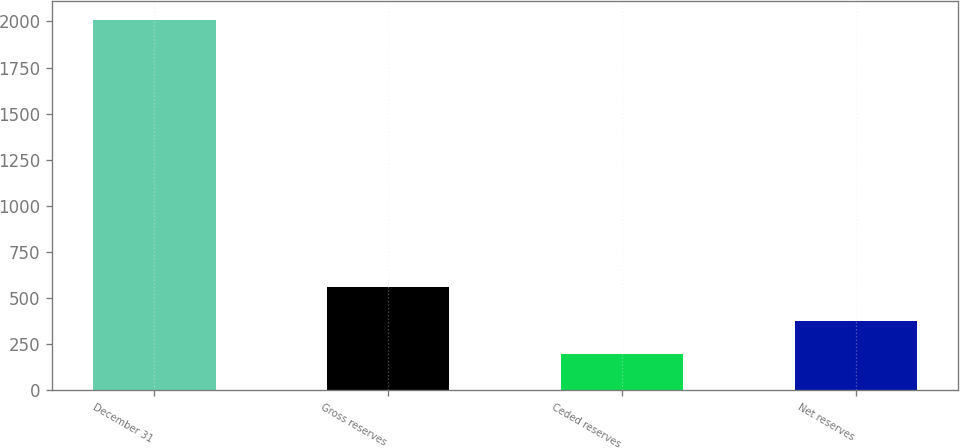Convert chart to OTSL. <chart><loc_0><loc_0><loc_500><loc_500><bar_chart><fcel>December 31<fcel>Gross reserves<fcel>Ceded reserves<fcel>Net reserves<nl><fcel>2009<fcel>558.6<fcel>196<fcel>377.3<nl></chart> 